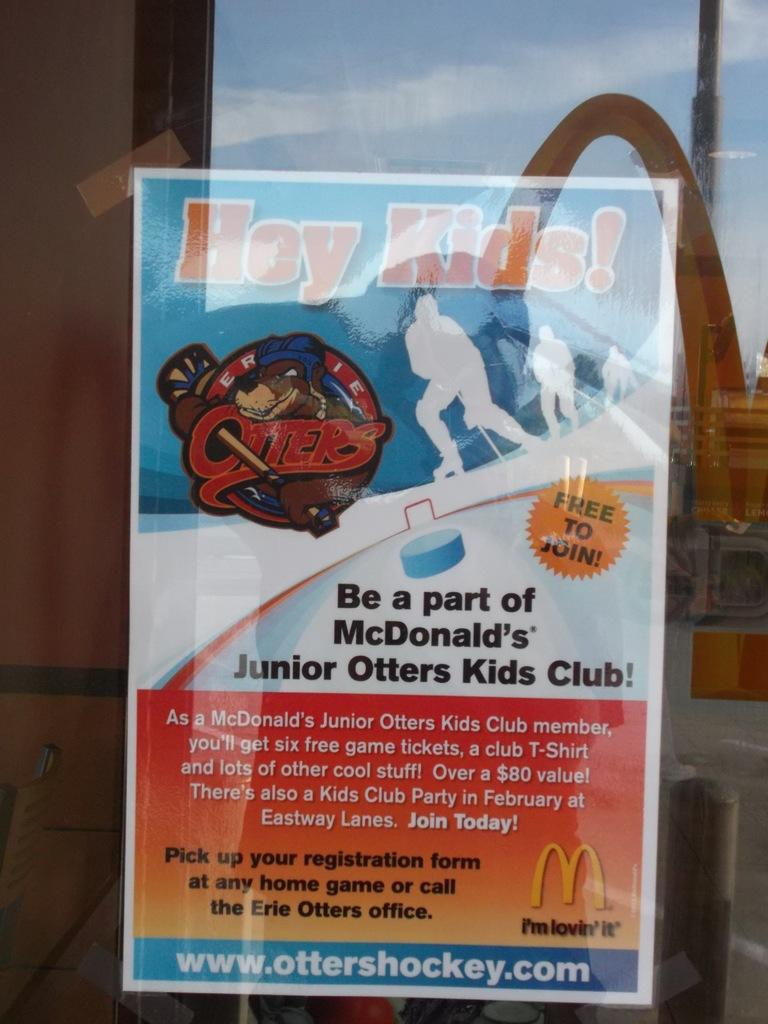Provide a one-sentence caption for the provided image. A posted sign in the window shows how to join the McDonald's Junior Otters Kids Club. 